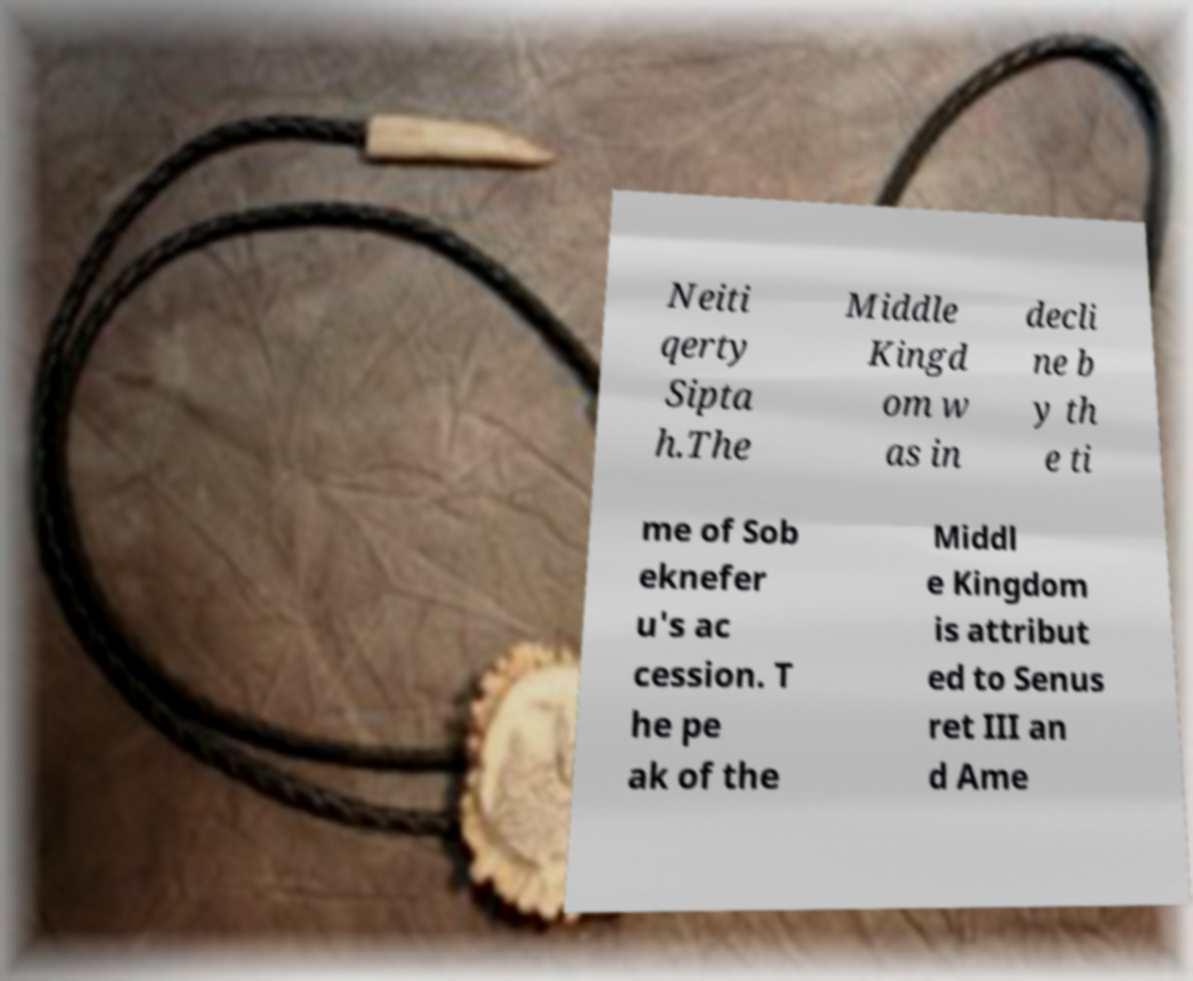Could you assist in decoding the text presented in this image and type it out clearly? Neiti qerty Sipta h.The Middle Kingd om w as in decli ne b y th e ti me of Sob eknefer u's ac cession. T he pe ak of the Middl e Kingdom is attribut ed to Senus ret III an d Ame 